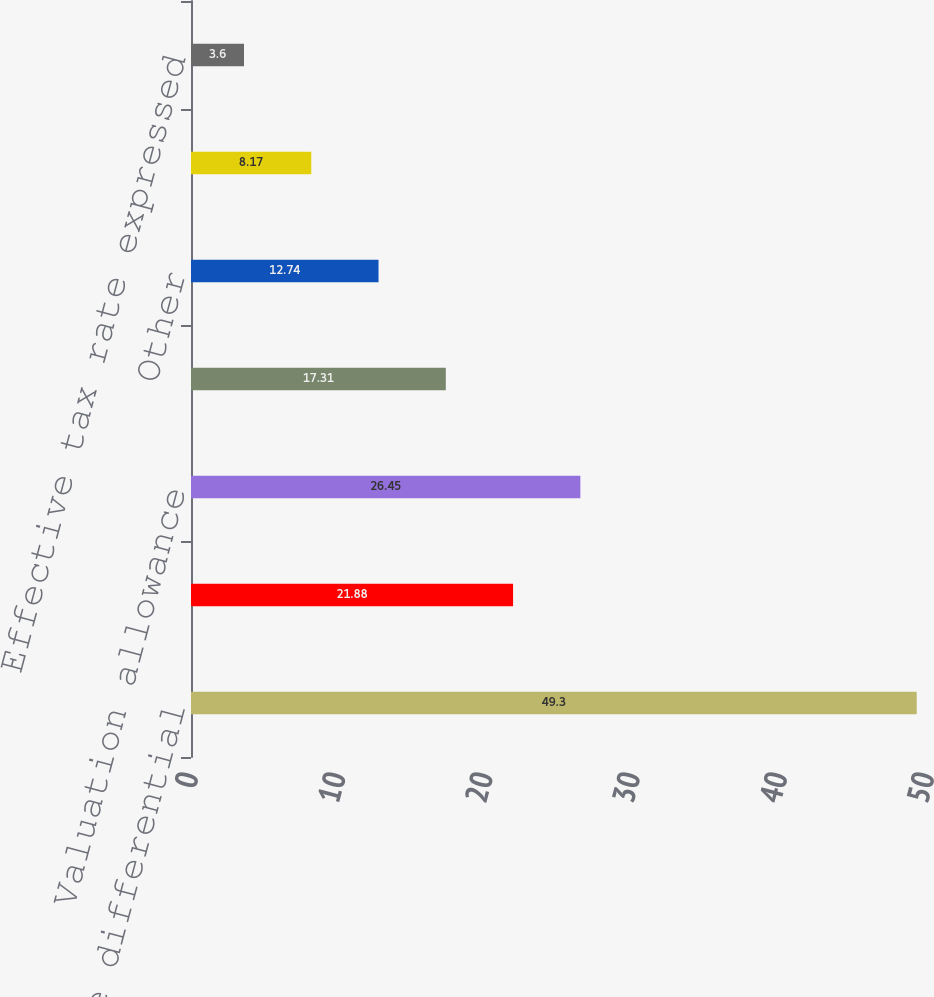<chart> <loc_0><loc_0><loc_500><loc_500><bar_chart><fcel>Foreign rate differential<fcel>Tax law change<fcel>Valuation allowance<fcel>Uncertain tax positions<fcel>Other<fcel>(Benefit) provision for income<fcel>Effective tax rate expressed<nl><fcel>49.3<fcel>21.88<fcel>26.45<fcel>17.31<fcel>12.74<fcel>8.17<fcel>3.6<nl></chart> 